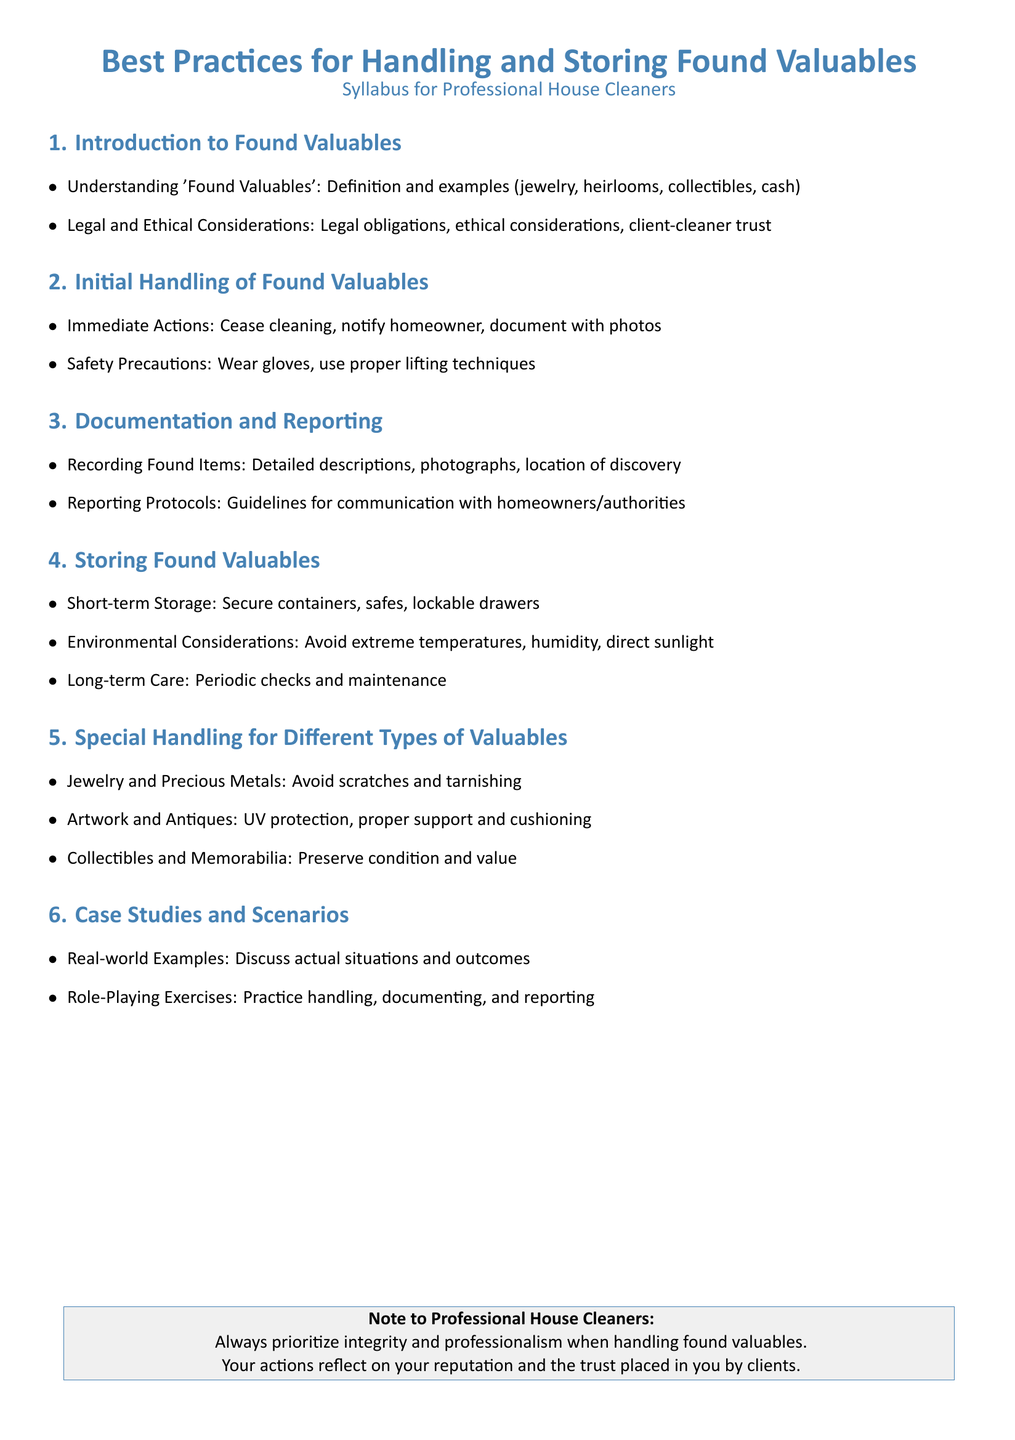what is the title of the document? The title of the document is stated prominently at the top of the syllabus, indicating its main focus and audience.
Answer: Best Practices for Handling and Storing Found Valuables what section discusses the initial actions after finding valuables? This section outlines what steps should be taken immediately upon discovering valuables, which includes crucial first actions.
Answer: Initial Handling of Found Valuables what are the two main considerations mentioned in the introduction? The introduction emphasizes two key areas that must be understood when dealing with found valuables, which set the context for the entire syllabus.
Answer: Legal and Ethical Considerations where should short-term storage of found valuables occur? This question directs us to the specific recommendations given for securing valuables found during cleaning, highlighting best storage practices.
Answer: Secure containers, safes, lockable drawers how should jewelry and precious metals be handled? This section notes specific care instructions for one category of valuables, focusing on preservation practices unique to that group.
Answer: Avoid scratches and tarnishing what is emphasized in the note to professional house cleaners? This note provides overarching advice for cleaners, linking to the ethical aspect of their role and the impact on their reputation.
Answer: Integrity and professionalism 